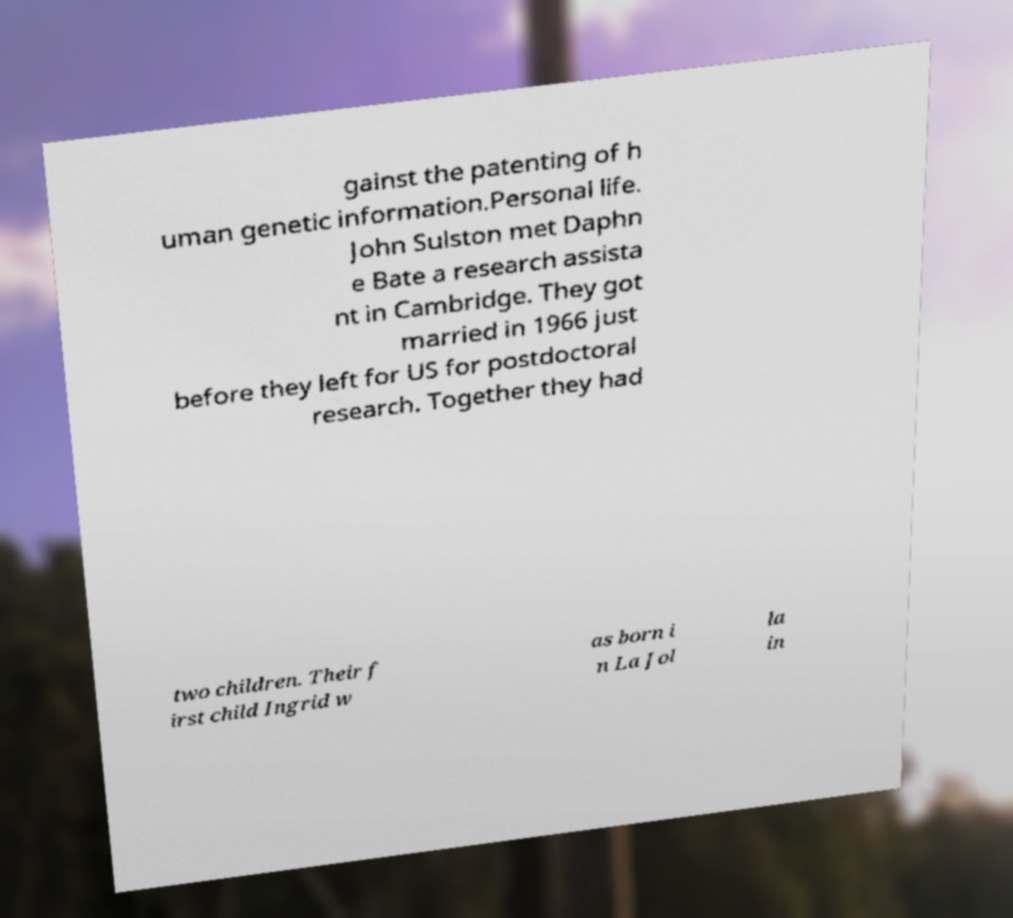What messages or text are displayed in this image? I need them in a readable, typed format. gainst the patenting of h uman genetic information.Personal life. John Sulston met Daphn e Bate a research assista nt in Cambridge. They got married in 1966 just before they left for US for postdoctoral research. Together they had two children. Their f irst child Ingrid w as born i n La Jol la in 